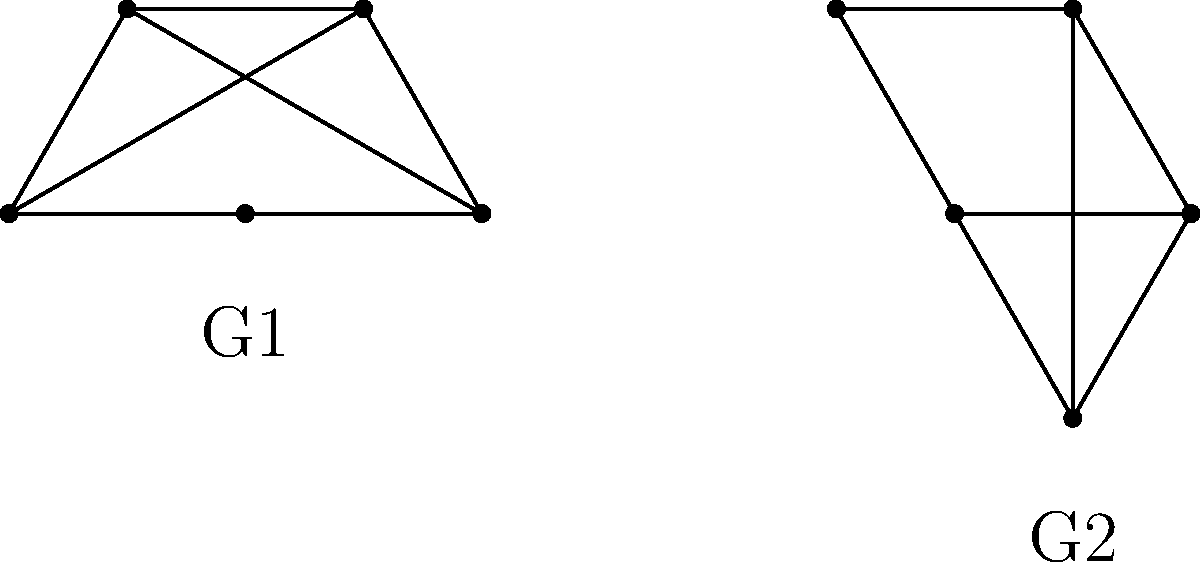Consider the two quantum graphs G1 and G2 shown above. Both graphs have 5 nodes and 7 edges, but with different arrangements. Are these graphs isomorphic? If so, provide the isomorphism mapping between the nodes of G1 and G2. If not, explain why. To determine if the graphs are isomorphic, we need to follow these steps:

1. Check if the graphs have the same number of nodes and edges:
   Both G1 and G2 have 5 nodes and 7 edges, satisfying this condition.

2. Compare the degree sequences of both graphs:
   G1: All nodes have degree 3.
   G2: All nodes have degree 3.
   The degree sequences match.

3. Look for a bijective mapping between the nodes that preserves adjacency:
   Let's try to map the nodes:
   - Choose a node in G1, say the top node. It's adjacent to 3 others.
   - In G2, the center node is adjacent to all others, so map the top node of G1 to the center of G2.
   - The remaining 4 nodes in both graphs form a cycle.
   - We can map these in a clockwise manner.

4. Verify that the mapping preserves all edges:
   - The central node in G2 connects to all others, corresponding to the top node in G1 connecting to all others (3 directly, 1 via an internal edge).
   - The cycle formed by the outer nodes in both graphs is preserved.
   - The internal edges in G1 (connecting opposite nodes) correspond to the edges through the center in G2.

5. Isomorphism mapping:
   Let's number the nodes of G1 clockwise from the top: 1, 2, 3, 4, 5
   And number the nodes of G2: center as 1, then clockwise from top-right: 2, 3, 4, 5
   The isomorphism is: 1 → 1, 2 → 2, 3 → 3, 4 → 4, 5 → 5

Therefore, the graphs are isomorphic, with the mapping described above preserving all adjacency relationships.
Answer: Yes, isomorphic. Mapping: 1→1, 2→2, 3→3, 4→4, 5→5. 